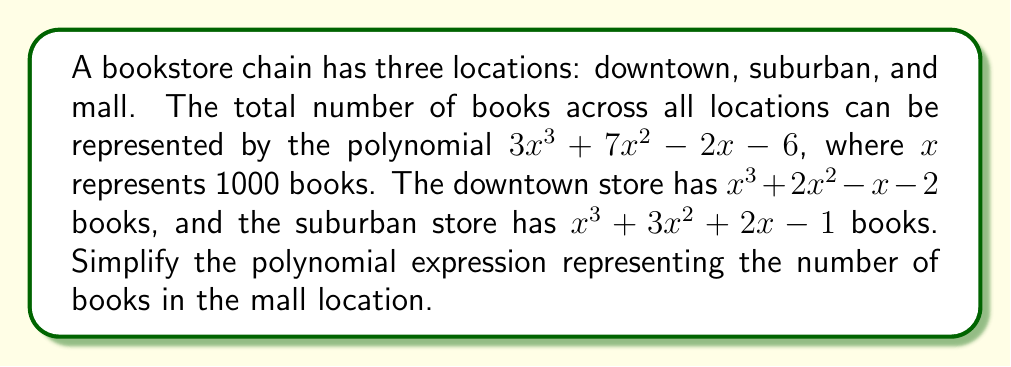Provide a solution to this math problem. To find the polynomial expression for the mall location, we need to subtract the polynomials for the downtown and suburban stores from the total polynomial.

Let's approach this step-by-step:

1) Total books: $3x^3 + 7x^2 - 2x - 6$
2) Downtown store: $x^3 + 2x^2 - x - 2$
3) Suburban store: $x^3 + 3x^2 + 2x - 1$

4) Mall store = Total - Downtown - Suburban

5) Let's subtract:
   $$(3x^3 + 7x^2 - 2x - 6) - (x^3 + 2x^2 - x - 2) - (x^3 + 3x^2 + 2x - 1)$$

6) Combining like terms:
   $$3x^3 + 7x^2 - 2x - 6$$
   $$-x^3 - 2x^2 + x + 2$$
   $$-x^3 - 3x^2 - 2x + 1$$

7) Adding these polynomials:
   $$3x^3 + 7x^2 - 2x - 6$$
   $$-x^3 - 2x^2 + x + 2$$
   $$-x^3 - 3x^2 - 2x + 1$$
   $$= x^3 + 2x^2 - 3x - 3$$

Therefore, the simplified polynomial expression for the mall location is $x^3 + 2x^2 - 3x - 3$.
Answer: $x^3 + 2x^2 - 3x - 3$ 